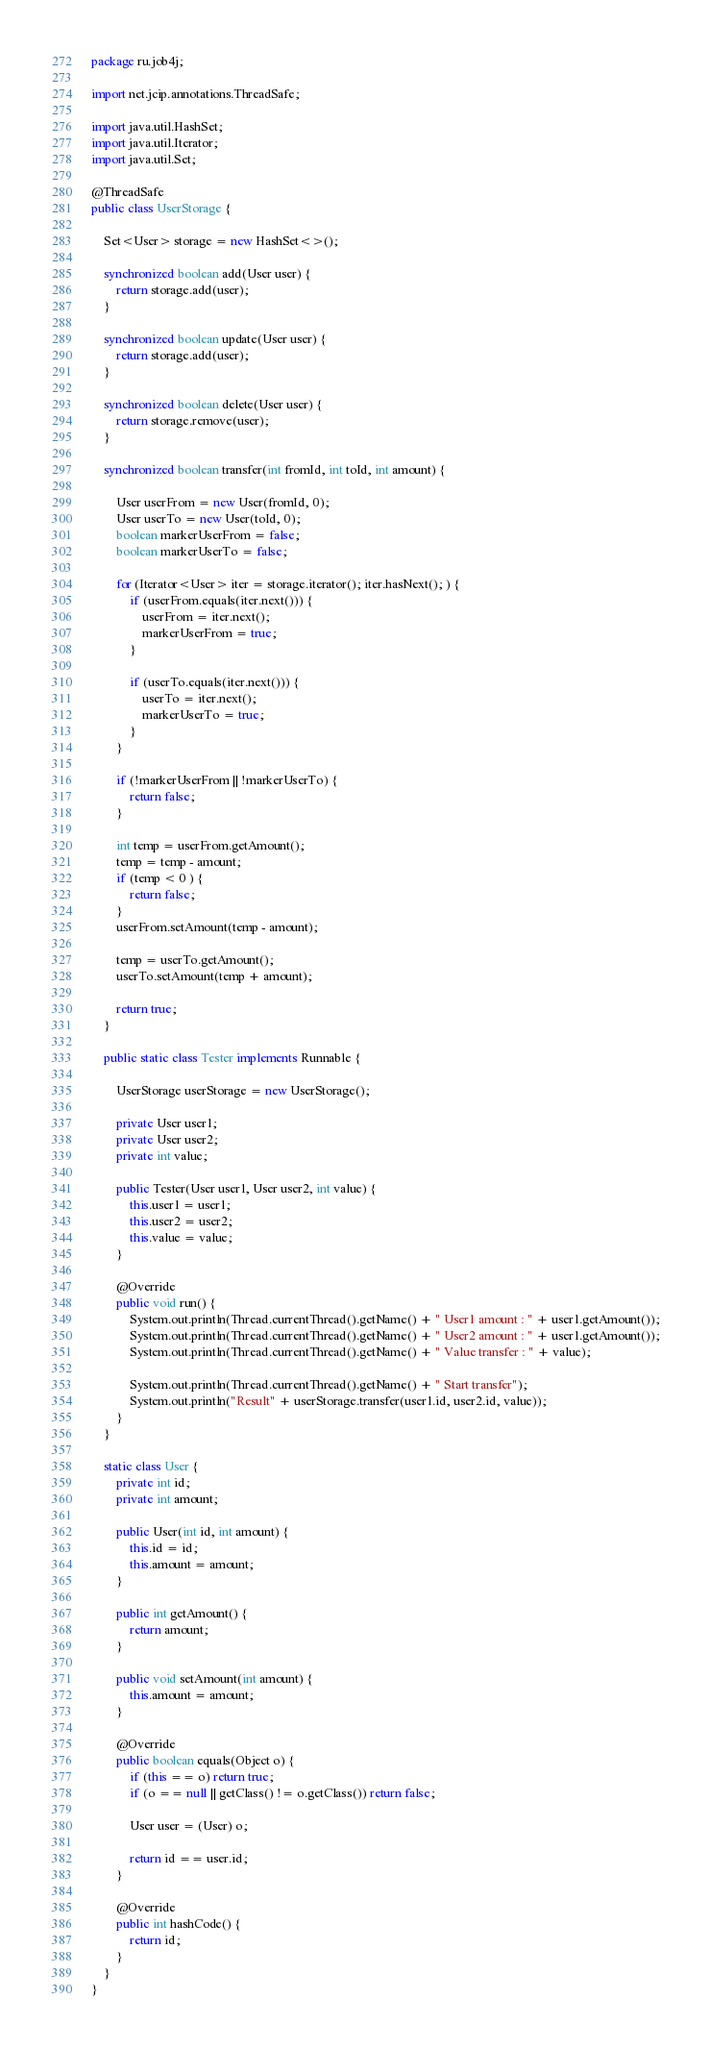Convert code to text. <code><loc_0><loc_0><loc_500><loc_500><_Java_>package ru.job4j;

import net.jcip.annotations.ThreadSafe;

import java.util.HashSet;
import java.util.Iterator;
import java.util.Set;

@ThreadSafe
public class UserStorage {

    Set<User> storage = new HashSet<>();

    synchronized boolean add(User user) {
        return storage.add(user);
    }

    synchronized boolean update(User user) {
        return storage.add(user);
    }

    synchronized boolean delete(User user) {
        return storage.remove(user);
    }

    synchronized boolean transfer(int fromId, int toId, int amount) {

        User userFrom = new User(fromId, 0);
        User userTo = new User(toId, 0);
        boolean markerUserFrom = false;
        boolean markerUserTo = false;

        for (Iterator<User> iter = storage.iterator(); iter.hasNext(); ) {
            if (userFrom.equals(iter.next())) {
                userFrom = iter.next();
                markerUserFrom = true;
            }

            if (userTo.equals(iter.next())) {
                userTo = iter.next();
                markerUserTo = true;
            }
        }

        if (!markerUserFrom || !markerUserTo) {
            return false;
        }

        int temp = userFrom.getAmount();
        temp = temp - amount;
        if (temp < 0 ) {
            return false;
        }
        userFrom.setAmount(temp - amount);

        temp = userTo.getAmount();
        userTo.setAmount(temp + amount);

        return true;
    }

    public static class Tester implements Runnable {

        UserStorage userStorage = new UserStorage();

        private User user1;
        private User user2;
        private int value;

        public Tester(User user1, User user2, int value) {
            this.user1 = user1;
            this.user2 = user2;
            this.value = value;
        }

        @Override
        public void run() {
            System.out.println(Thread.currentThread().getName() + " User1 amount : " + user1.getAmount());
            System.out.println(Thread.currentThread().getName() + " User2 amount : " + user1.getAmount());
            System.out.println(Thread.currentThread().getName() + " Value transfer : " + value);

            System.out.println(Thread.currentThread().getName() + " Start transfer");
            System.out.println("Result" + userStorage.transfer(user1.id, user2.id, value));
        }
    }

    static class User {
        private int id;
        private int amount;

        public User(int id, int amount) {
            this.id = id;
            this.amount = amount;
        }

        public int getAmount() {
            return amount;
        }

        public void setAmount(int amount) {
            this.amount = amount;
        }

        @Override
        public boolean equals(Object o) {
            if (this == o) return true;
            if (o == null || getClass() != o.getClass()) return false;

            User user = (User) o;

            return id == user.id;
        }

        @Override
        public int hashCode() {
            return id;
        }
    }
}
</code> 